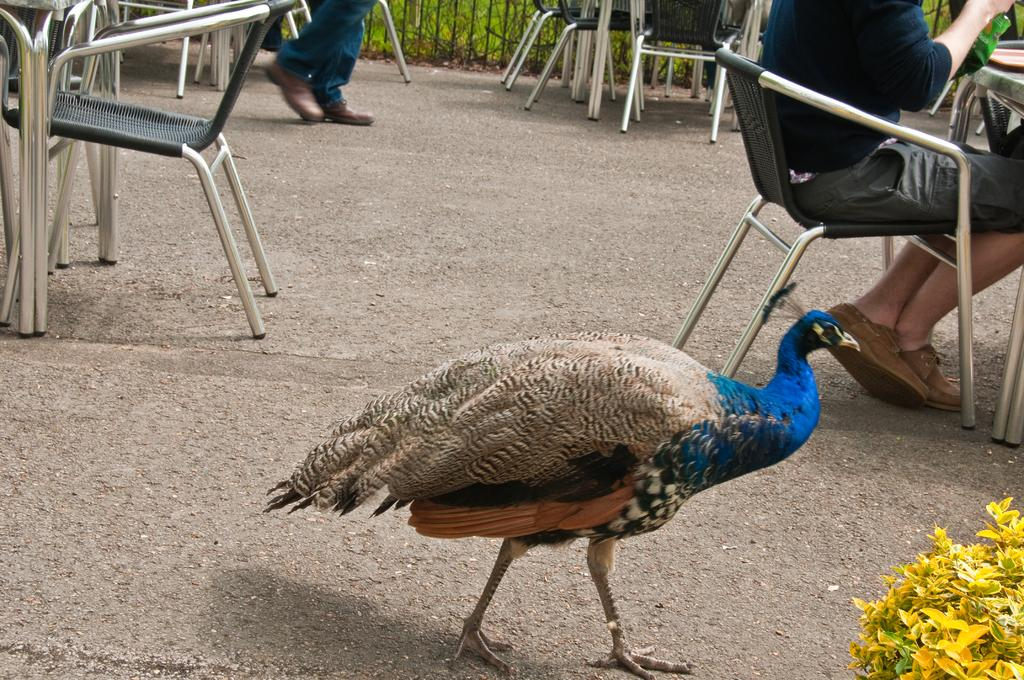What type of animal is in the image? There is a peacock in the image. What is the person in the image doing? The person is seated on a chair in the image. How many chairs are visible in the image? There are at least two chairs in the image. What year is depicted in the image? The image does not depict a specific year; it is a snapshot of the present moment. 